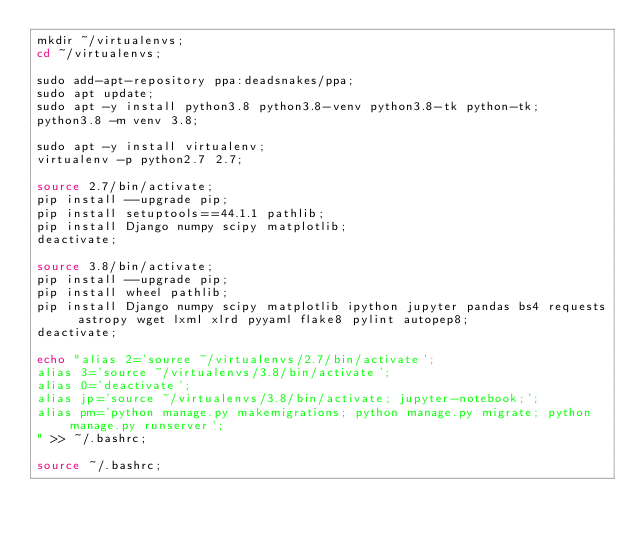<code> <loc_0><loc_0><loc_500><loc_500><_Bash_>mkdir ~/virtualenvs;
cd ~/virtualenvs;

sudo add-apt-repository ppa:deadsnakes/ppa;
sudo apt update;
sudo apt -y install python3.8 python3.8-venv python3.8-tk python-tk;
python3.8 -m venv 3.8;

sudo apt -y install virtualenv;
virtualenv -p python2.7 2.7;

source 2.7/bin/activate;
pip install --upgrade pip;
pip install setuptools==44.1.1 pathlib;
pip install Django numpy scipy matplotlib;
deactivate;

source 3.8/bin/activate;
pip install --upgrade pip;
pip install wheel pathlib;
pip install Django numpy scipy matplotlib ipython jupyter pandas bs4 requests astropy wget lxml xlrd pyyaml flake8 pylint autopep8;
deactivate;

echo "alias 2='source ~/virtualenvs/2.7/bin/activate';
alias 3='source ~/virtualenvs/3.8/bin/activate';
alias 0='deactivate';
alias jp='source ~/virtualenvs/3.8/bin/activate; jupyter-notebook;';
alias pm='python manage.py makemigrations; python manage.py migrate; python manage.py runserver';
" >> ~/.bashrc;

source ~/.bashrc;
</code> 